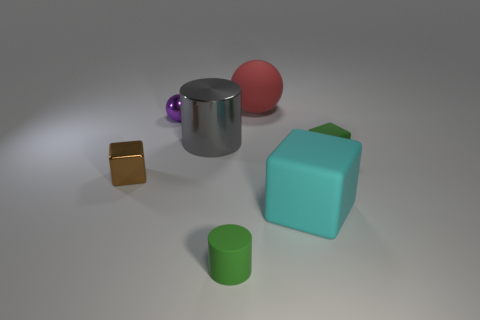Subtract all green matte blocks. How many blocks are left? 2 Add 3 big matte blocks. How many objects exist? 10 Subtract all brown blocks. How many blocks are left? 2 Subtract all cylinders. How many objects are left? 5 Subtract 2 cubes. How many cubes are left? 1 Subtract all big objects. Subtract all tiny blue cylinders. How many objects are left? 4 Add 2 brown objects. How many brown objects are left? 3 Add 2 cyan rubber things. How many cyan rubber things exist? 3 Subtract 0 gray blocks. How many objects are left? 7 Subtract all purple cylinders. Subtract all yellow balls. How many cylinders are left? 2 